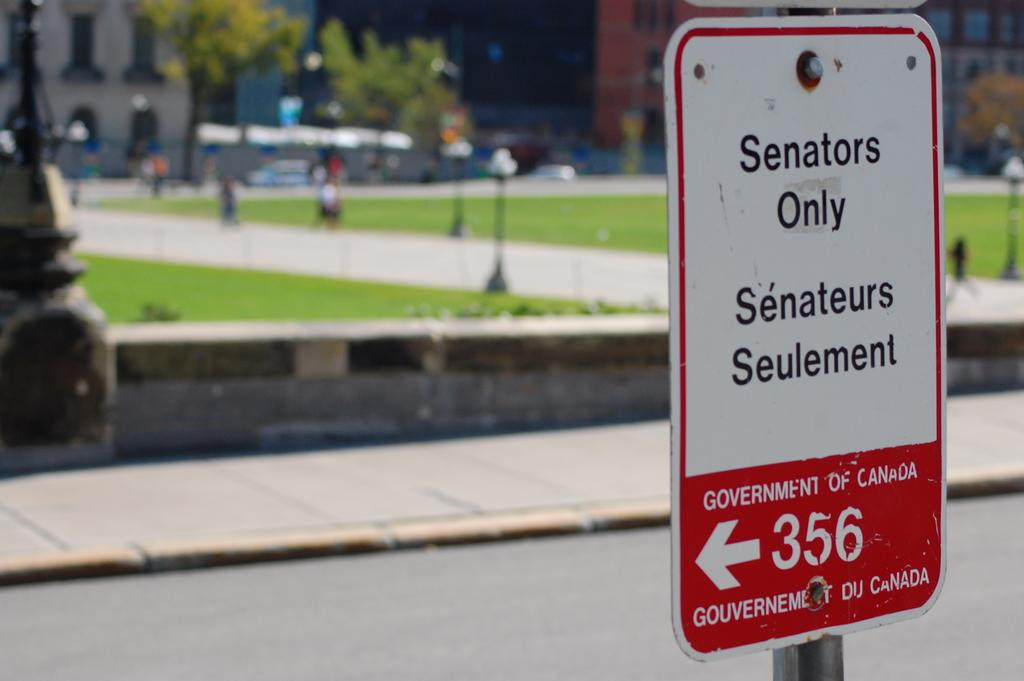What is on the board that is visible in the image? There is a board with writing in the image. What can be seen in the distance in the image? There are buildings and poles in the background of the image. How would you describe the background of the image? The background of the image is blurred. What type of flame can be seen on the board in the image? There is no flame present on the board or in the image. 